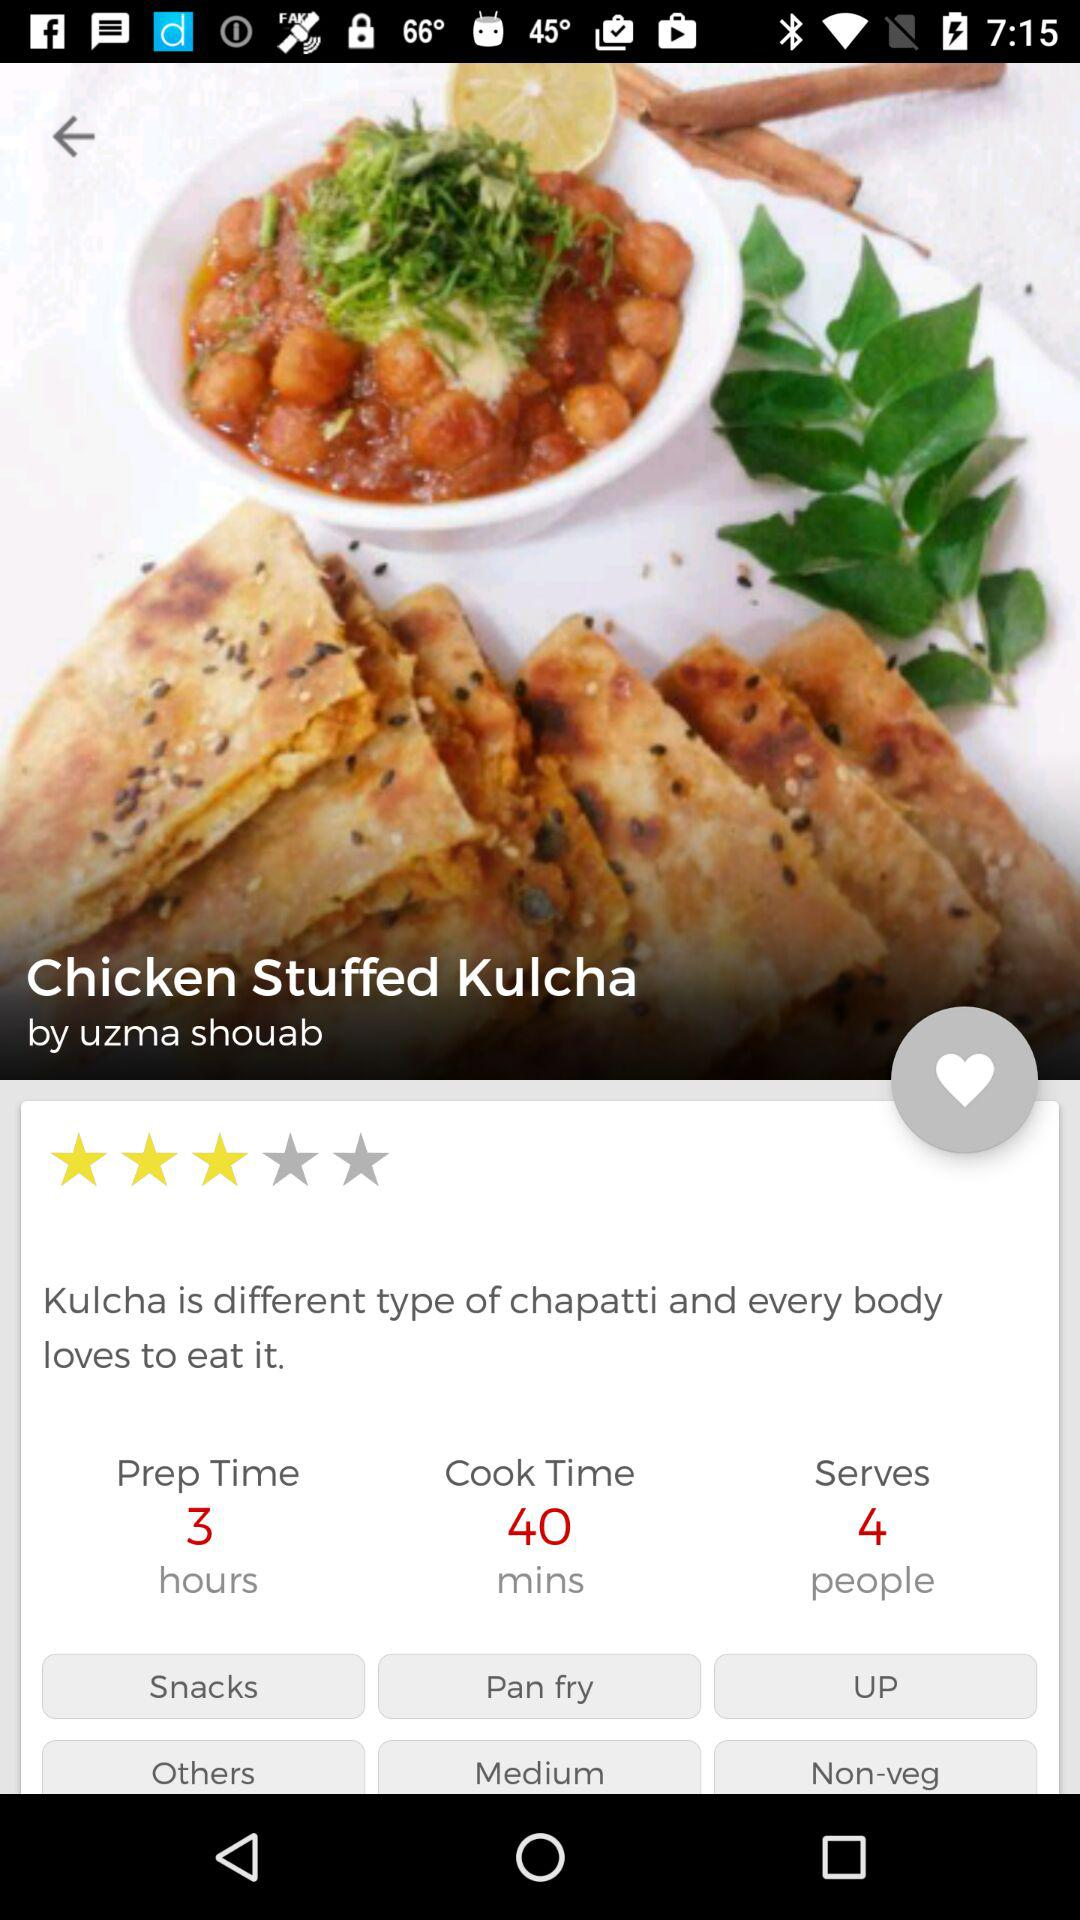How much time does it take to prepare this dish? The preparation time for Chicken Stuffed Kulcha is 3 hours, with an additional cooking time of 40 minutes as shown in the image. Is this a dish that I can serve as a main course or is it more of a side dish? Chicken Stuffed Kulcha can be versatile. It can serve as a filling main course, or be paired with other dishes as a substantial side. 